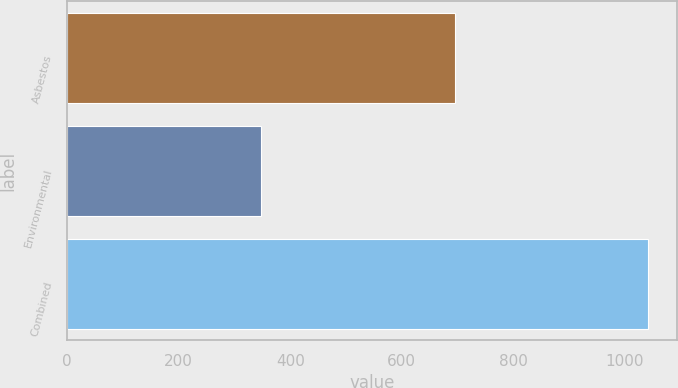<chart> <loc_0><loc_0><loc_500><loc_500><bar_chart><fcel>Asbestos<fcel>Environmental<fcel>Combined<nl><fcel>695<fcel>347<fcel>1042<nl></chart> 